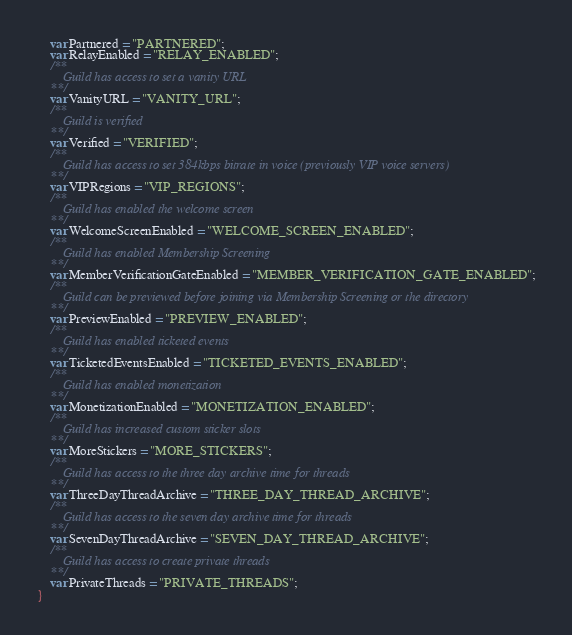<code> <loc_0><loc_0><loc_500><loc_500><_Haxe_>	var Partnered = "PARTNERED";
	var RelayEnabled = "RELAY_ENABLED";
	/**
		Guild has access to set a vanity URL
	**/
	var VanityURL = "VANITY_URL";
	/**
		Guild is verified
	**/
	var Verified = "VERIFIED";
	/**
		Guild has access to set 384kbps bitrate in voice (previously VIP voice servers)
	**/
	var VIPRegions = "VIP_REGIONS";
	/**
		Guild has enabled the welcome screen
	**/
	var WelcomeScreenEnabled = "WELCOME_SCREEN_ENABLED";
	/**
		Guild has enabled Membership Screening
	**/
	var MemberVerificationGateEnabled = "MEMBER_VERIFICATION_GATE_ENABLED";
	/**
		Guild can be previewed before joining via Membership Screening or the directory
	**/
	var PreviewEnabled = "PREVIEW_ENABLED";
	/**
		Guild has enabled ticketed events
	**/
	var TicketedEventsEnabled = "TICKETED_EVENTS_ENABLED";
	/**
		Guild has enabled monetization
	**/
	var MonetizationEnabled = "MONETIZATION_ENABLED";
	/**
		Guild has increased custom sticker slots
	**/
	var MoreStickers = "MORE_STICKERS";
	/**
		Guild has access to the three day archive time for threads
	**/
	var ThreeDayThreadArchive = "THREE_DAY_THREAD_ARCHIVE";
	/**
		Guild has access to the seven day archive time for threads
	**/
	var SevenDayThreadArchive = "SEVEN_DAY_THREAD_ARCHIVE";
	/**
		Guild has access to create private threads
	**/
	var PrivateThreads = "PRIVATE_THREADS";
}</code> 